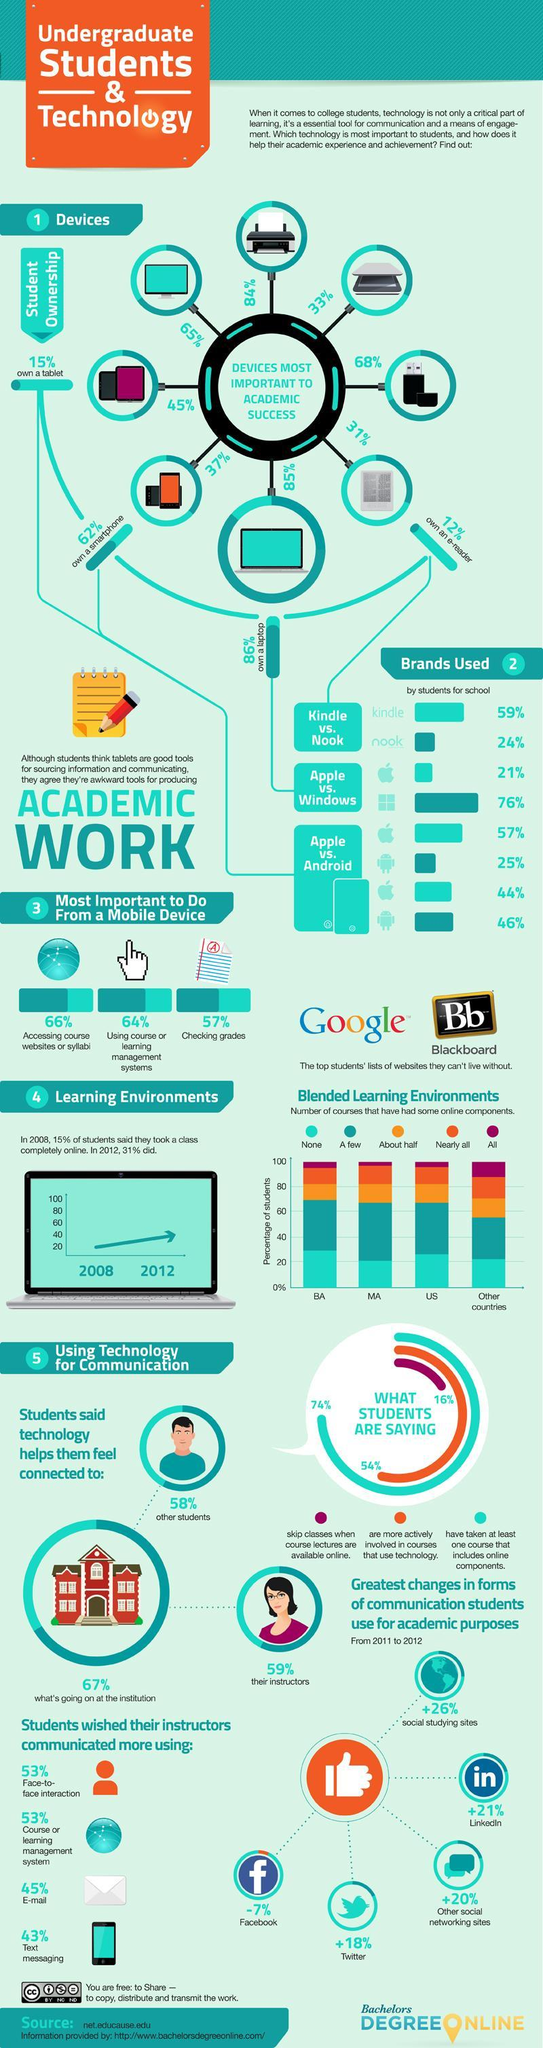How many of the students are actively involved in courses that use technology?
Answer the question with a short phrase. 54% Which brand of laptops are used by a higher number of students - Apple or Windows? windows What percent have taken at least one course with online components? 74% Which device is more essential for students - scanner or printer? printer What percent of smartphone users use android phones? 46% What percent of smartphone users use Apple phones? 44% How many of the students skip classes when course lectures are available online? 16% How essential (in percentage) is a printer in academic performance and achievement? 84% Which device is used by higher number of students- tablet or laptop? laptop 